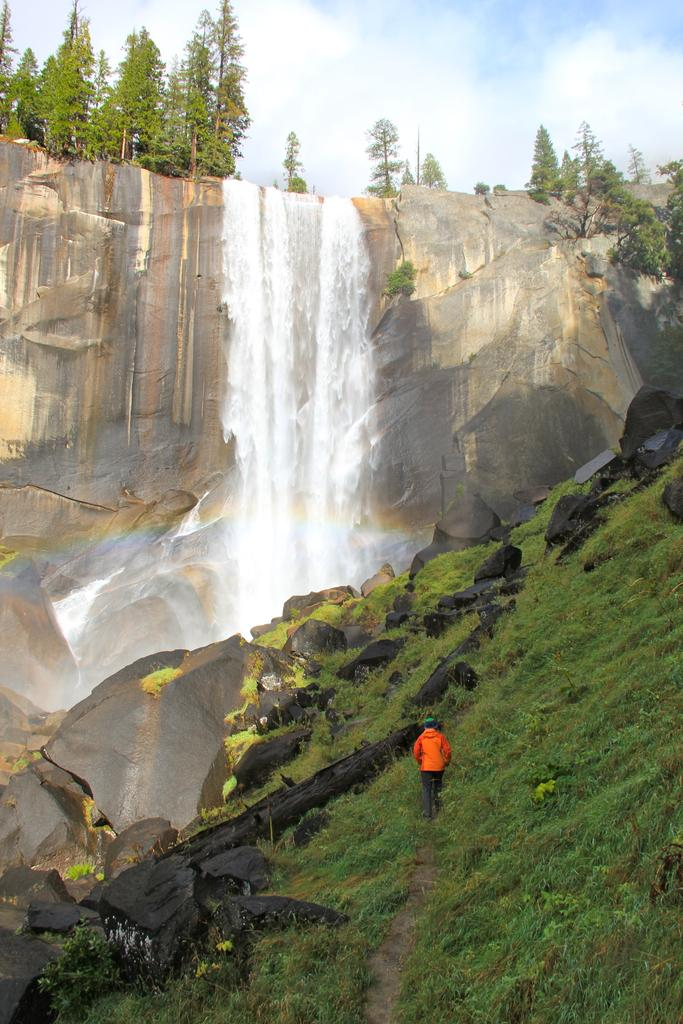What is the main feature in the center of the image? There is a waterfall in the center of the image. Can you describe any activity taking place in the image? There is a person walking in the image. What type of vegetation is present at the bottom of the image? Grass is present at the bottom of the image. What other objects can be seen at the bottom of the image? Rocks are visible at the bottom of the image. What can be seen in the background of the image? There are trees and the sky visible in the background of the image. What type of wool is being used to knit the mother's sweater in the image? There is no wool, mother, or sweater present in the image. 